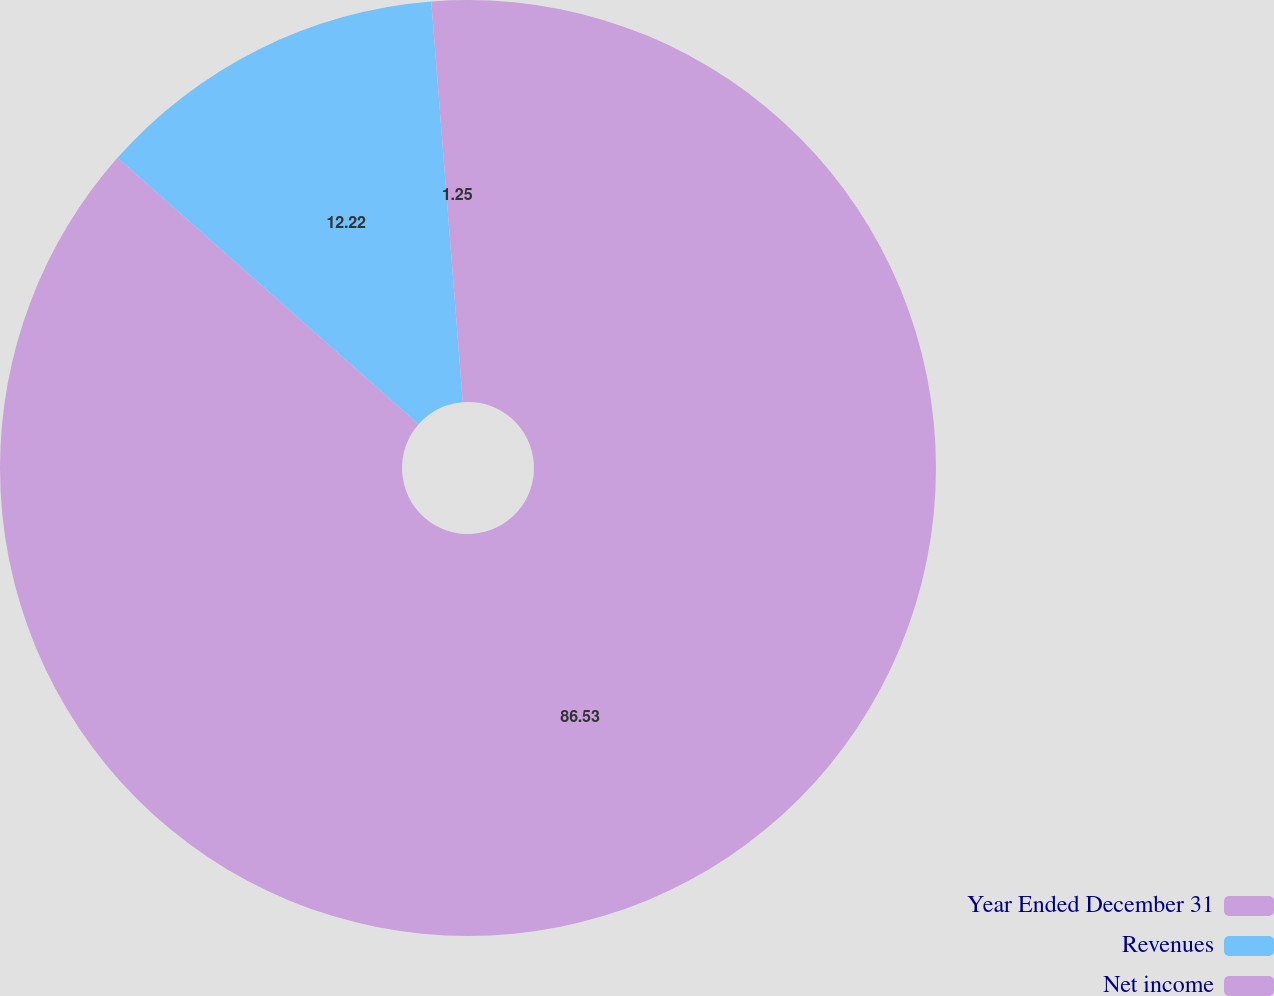Convert chart. <chart><loc_0><loc_0><loc_500><loc_500><pie_chart><fcel>Year Ended December 31<fcel>Revenues<fcel>Net income<nl><fcel>86.53%<fcel>12.22%<fcel>1.25%<nl></chart> 